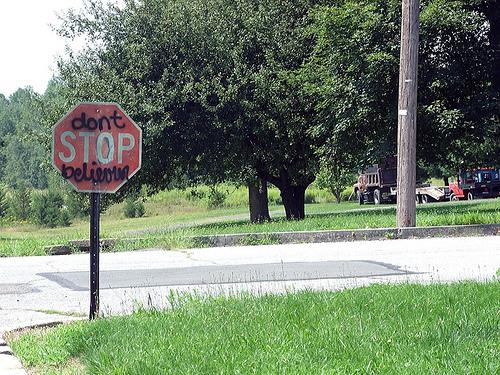Question: what is in the photo?
Choices:
A. Flowers.
B. Forest.
C. Trees.
D. Animals.
Answer with the letter. Answer: C Question: what else is visible?
Choices:
A. Traffic light.
B. Speed limit sign.
C. Street sign.
D. Stop sign.
Answer with the letter. Answer: D 